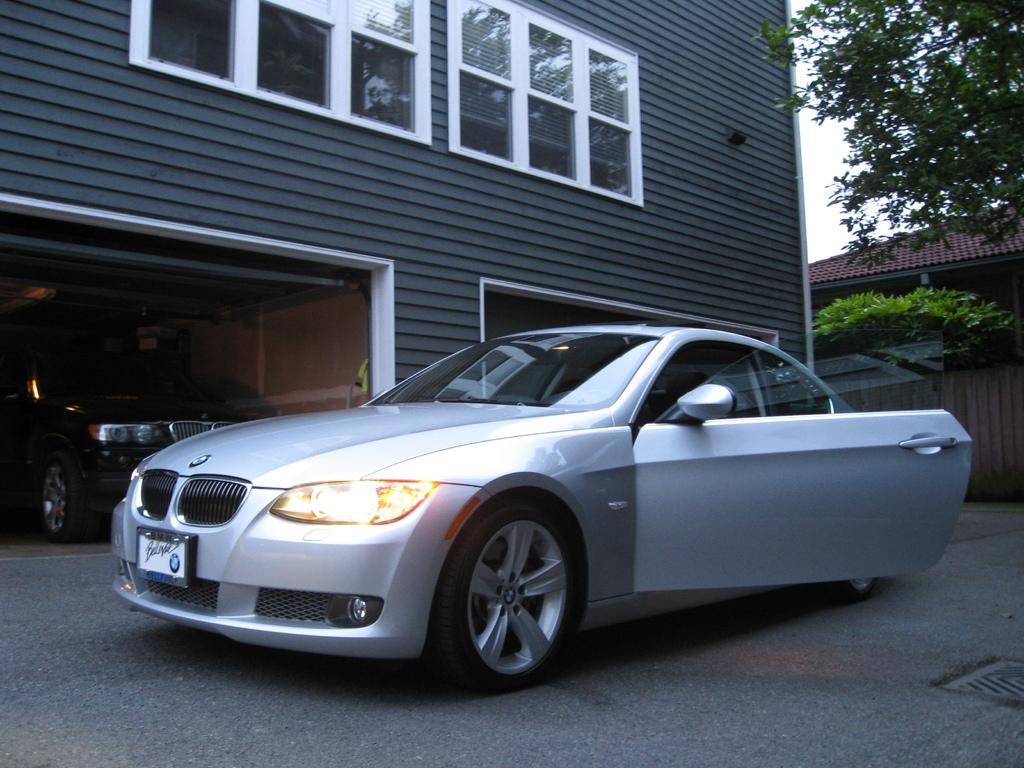What is the main subject of the image? There is a car on the road in the image. What can be seen in the background of the image? There are houses, trees, and the sky visible in the background of the image. What role does the actor play in the image? There is no actor present in the image; it features a car on the road and background elements. Where is the cellar located in the image? There is no cellar present in the image. 